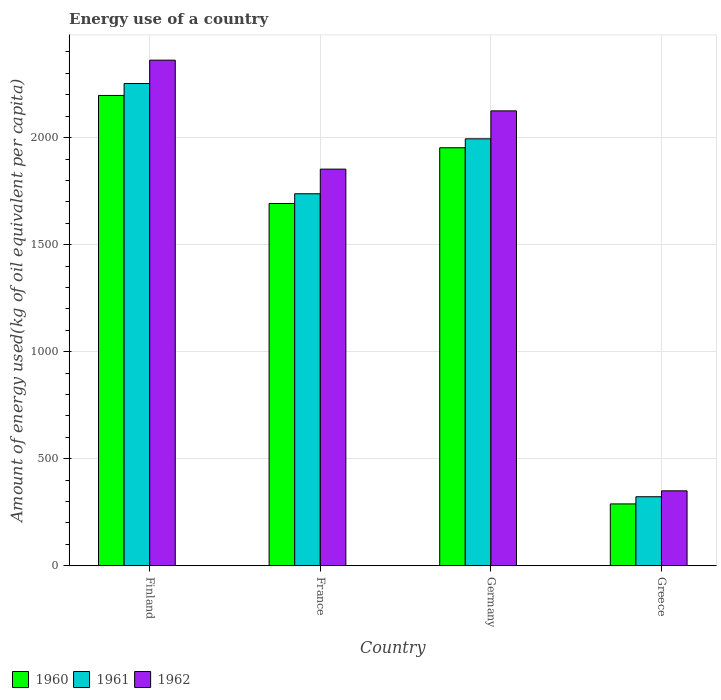How many different coloured bars are there?
Your answer should be compact. 3. Are the number of bars per tick equal to the number of legend labels?
Provide a short and direct response. Yes. Are the number of bars on each tick of the X-axis equal?
Make the answer very short. Yes. What is the label of the 2nd group of bars from the left?
Offer a very short reply. France. What is the amount of energy used in in 1962 in Germany?
Give a very brief answer. 2124.85. Across all countries, what is the maximum amount of energy used in in 1961?
Make the answer very short. 2252.78. Across all countries, what is the minimum amount of energy used in in 1961?
Provide a short and direct response. 322.49. In which country was the amount of energy used in in 1962 maximum?
Provide a succinct answer. Finland. What is the total amount of energy used in in 1961 in the graph?
Keep it short and to the point. 6307.28. What is the difference between the amount of energy used in in 1962 in France and that in Greece?
Make the answer very short. 1502.63. What is the difference between the amount of energy used in in 1961 in Finland and the amount of energy used in in 1960 in Germany?
Provide a short and direct response. 300.19. What is the average amount of energy used in in 1961 per country?
Give a very brief answer. 1576.82. What is the difference between the amount of energy used in of/in 1960 and amount of energy used in of/in 1961 in Germany?
Your response must be concise. -41.74. What is the ratio of the amount of energy used in in 1962 in France to that in Greece?
Your answer should be compact. 5.29. Is the amount of energy used in in 1960 in Germany less than that in Greece?
Your response must be concise. No. Is the difference between the amount of energy used in in 1960 in Finland and France greater than the difference between the amount of energy used in in 1961 in Finland and France?
Your answer should be very brief. No. What is the difference between the highest and the second highest amount of energy used in in 1961?
Your answer should be compact. -256.64. What is the difference between the highest and the lowest amount of energy used in in 1961?
Provide a succinct answer. 1930.29. What does the 3rd bar from the left in Germany represents?
Keep it short and to the point. 1962. What does the 1st bar from the right in Greece represents?
Offer a terse response. 1962. Is it the case that in every country, the sum of the amount of energy used in in 1961 and amount of energy used in in 1962 is greater than the amount of energy used in in 1960?
Offer a very short reply. Yes. Are all the bars in the graph horizontal?
Your response must be concise. No. What is the difference between two consecutive major ticks on the Y-axis?
Your answer should be compact. 500. Are the values on the major ticks of Y-axis written in scientific E-notation?
Ensure brevity in your answer.  No. Where does the legend appear in the graph?
Ensure brevity in your answer.  Bottom left. What is the title of the graph?
Provide a succinct answer. Energy use of a country. What is the label or title of the Y-axis?
Make the answer very short. Amount of energy used(kg of oil equivalent per capita). What is the Amount of energy used(kg of oil equivalent per capita) in 1960 in Finland?
Make the answer very short. 2196.95. What is the Amount of energy used(kg of oil equivalent per capita) in 1961 in Finland?
Make the answer very short. 2252.78. What is the Amount of energy used(kg of oil equivalent per capita) of 1962 in Finland?
Ensure brevity in your answer.  2361.74. What is the Amount of energy used(kg of oil equivalent per capita) in 1960 in France?
Give a very brief answer. 1692.26. What is the Amount of energy used(kg of oil equivalent per capita) in 1961 in France?
Provide a succinct answer. 1737.69. What is the Amount of energy used(kg of oil equivalent per capita) of 1962 in France?
Make the answer very short. 1852.74. What is the Amount of energy used(kg of oil equivalent per capita) of 1960 in Germany?
Provide a succinct answer. 1952.59. What is the Amount of energy used(kg of oil equivalent per capita) of 1961 in Germany?
Offer a terse response. 1994.32. What is the Amount of energy used(kg of oil equivalent per capita) of 1962 in Germany?
Offer a terse response. 2124.85. What is the Amount of energy used(kg of oil equivalent per capita) in 1960 in Greece?
Provide a succinct answer. 289.06. What is the Amount of energy used(kg of oil equivalent per capita) in 1961 in Greece?
Keep it short and to the point. 322.49. What is the Amount of energy used(kg of oil equivalent per capita) in 1962 in Greece?
Offer a very short reply. 350.1. Across all countries, what is the maximum Amount of energy used(kg of oil equivalent per capita) of 1960?
Offer a terse response. 2196.95. Across all countries, what is the maximum Amount of energy used(kg of oil equivalent per capita) of 1961?
Provide a short and direct response. 2252.78. Across all countries, what is the maximum Amount of energy used(kg of oil equivalent per capita) in 1962?
Your answer should be compact. 2361.74. Across all countries, what is the minimum Amount of energy used(kg of oil equivalent per capita) in 1960?
Offer a terse response. 289.06. Across all countries, what is the minimum Amount of energy used(kg of oil equivalent per capita) in 1961?
Keep it short and to the point. 322.49. Across all countries, what is the minimum Amount of energy used(kg of oil equivalent per capita) in 1962?
Provide a succinct answer. 350.1. What is the total Amount of energy used(kg of oil equivalent per capita) in 1960 in the graph?
Your answer should be very brief. 6130.86. What is the total Amount of energy used(kg of oil equivalent per capita) of 1961 in the graph?
Give a very brief answer. 6307.28. What is the total Amount of energy used(kg of oil equivalent per capita) in 1962 in the graph?
Give a very brief answer. 6689.43. What is the difference between the Amount of energy used(kg of oil equivalent per capita) in 1960 in Finland and that in France?
Provide a short and direct response. 504.69. What is the difference between the Amount of energy used(kg of oil equivalent per capita) of 1961 in Finland and that in France?
Offer a very short reply. 515.09. What is the difference between the Amount of energy used(kg of oil equivalent per capita) in 1962 in Finland and that in France?
Give a very brief answer. 509.01. What is the difference between the Amount of energy used(kg of oil equivalent per capita) in 1960 in Finland and that in Germany?
Give a very brief answer. 244.36. What is the difference between the Amount of energy used(kg of oil equivalent per capita) in 1961 in Finland and that in Germany?
Provide a succinct answer. 258.45. What is the difference between the Amount of energy used(kg of oil equivalent per capita) of 1962 in Finland and that in Germany?
Give a very brief answer. 236.9. What is the difference between the Amount of energy used(kg of oil equivalent per capita) in 1960 in Finland and that in Greece?
Provide a succinct answer. 1907.9. What is the difference between the Amount of energy used(kg of oil equivalent per capita) in 1961 in Finland and that in Greece?
Your response must be concise. 1930.29. What is the difference between the Amount of energy used(kg of oil equivalent per capita) in 1962 in Finland and that in Greece?
Offer a terse response. 2011.64. What is the difference between the Amount of energy used(kg of oil equivalent per capita) of 1960 in France and that in Germany?
Make the answer very short. -260.33. What is the difference between the Amount of energy used(kg of oil equivalent per capita) in 1961 in France and that in Germany?
Offer a terse response. -256.64. What is the difference between the Amount of energy used(kg of oil equivalent per capita) in 1962 in France and that in Germany?
Your response must be concise. -272.11. What is the difference between the Amount of energy used(kg of oil equivalent per capita) of 1960 in France and that in Greece?
Make the answer very short. 1403.2. What is the difference between the Amount of energy used(kg of oil equivalent per capita) of 1961 in France and that in Greece?
Make the answer very short. 1415.2. What is the difference between the Amount of energy used(kg of oil equivalent per capita) in 1962 in France and that in Greece?
Your response must be concise. 1502.63. What is the difference between the Amount of energy used(kg of oil equivalent per capita) in 1960 in Germany and that in Greece?
Keep it short and to the point. 1663.53. What is the difference between the Amount of energy used(kg of oil equivalent per capita) of 1961 in Germany and that in Greece?
Provide a short and direct response. 1671.83. What is the difference between the Amount of energy used(kg of oil equivalent per capita) of 1962 in Germany and that in Greece?
Make the answer very short. 1774.75. What is the difference between the Amount of energy used(kg of oil equivalent per capita) of 1960 in Finland and the Amount of energy used(kg of oil equivalent per capita) of 1961 in France?
Offer a very short reply. 459.26. What is the difference between the Amount of energy used(kg of oil equivalent per capita) in 1960 in Finland and the Amount of energy used(kg of oil equivalent per capita) in 1962 in France?
Offer a very short reply. 344.22. What is the difference between the Amount of energy used(kg of oil equivalent per capita) in 1961 in Finland and the Amount of energy used(kg of oil equivalent per capita) in 1962 in France?
Offer a terse response. 400.04. What is the difference between the Amount of energy used(kg of oil equivalent per capita) of 1960 in Finland and the Amount of energy used(kg of oil equivalent per capita) of 1961 in Germany?
Your answer should be compact. 202.63. What is the difference between the Amount of energy used(kg of oil equivalent per capita) in 1960 in Finland and the Amount of energy used(kg of oil equivalent per capita) in 1962 in Germany?
Your answer should be compact. 72.1. What is the difference between the Amount of energy used(kg of oil equivalent per capita) in 1961 in Finland and the Amount of energy used(kg of oil equivalent per capita) in 1962 in Germany?
Offer a terse response. 127.93. What is the difference between the Amount of energy used(kg of oil equivalent per capita) in 1960 in Finland and the Amount of energy used(kg of oil equivalent per capita) in 1961 in Greece?
Give a very brief answer. 1874.46. What is the difference between the Amount of energy used(kg of oil equivalent per capita) of 1960 in Finland and the Amount of energy used(kg of oil equivalent per capita) of 1962 in Greece?
Offer a terse response. 1846.85. What is the difference between the Amount of energy used(kg of oil equivalent per capita) in 1961 in Finland and the Amount of energy used(kg of oil equivalent per capita) in 1962 in Greece?
Your answer should be compact. 1902.68. What is the difference between the Amount of energy used(kg of oil equivalent per capita) in 1960 in France and the Amount of energy used(kg of oil equivalent per capita) in 1961 in Germany?
Your answer should be very brief. -302.06. What is the difference between the Amount of energy used(kg of oil equivalent per capita) of 1960 in France and the Amount of energy used(kg of oil equivalent per capita) of 1962 in Germany?
Ensure brevity in your answer.  -432.59. What is the difference between the Amount of energy used(kg of oil equivalent per capita) in 1961 in France and the Amount of energy used(kg of oil equivalent per capita) in 1962 in Germany?
Your answer should be very brief. -387.16. What is the difference between the Amount of energy used(kg of oil equivalent per capita) of 1960 in France and the Amount of energy used(kg of oil equivalent per capita) of 1961 in Greece?
Keep it short and to the point. 1369.77. What is the difference between the Amount of energy used(kg of oil equivalent per capita) of 1960 in France and the Amount of energy used(kg of oil equivalent per capita) of 1962 in Greece?
Make the answer very short. 1342.16. What is the difference between the Amount of energy used(kg of oil equivalent per capita) in 1961 in France and the Amount of energy used(kg of oil equivalent per capita) in 1962 in Greece?
Ensure brevity in your answer.  1387.59. What is the difference between the Amount of energy used(kg of oil equivalent per capita) in 1960 in Germany and the Amount of energy used(kg of oil equivalent per capita) in 1961 in Greece?
Offer a very short reply. 1630.1. What is the difference between the Amount of energy used(kg of oil equivalent per capita) of 1960 in Germany and the Amount of energy used(kg of oil equivalent per capita) of 1962 in Greece?
Offer a terse response. 1602.49. What is the difference between the Amount of energy used(kg of oil equivalent per capita) in 1961 in Germany and the Amount of energy used(kg of oil equivalent per capita) in 1962 in Greece?
Make the answer very short. 1644.22. What is the average Amount of energy used(kg of oil equivalent per capita) in 1960 per country?
Offer a very short reply. 1532.72. What is the average Amount of energy used(kg of oil equivalent per capita) in 1961 per country?
Keep it short and to the point. 1576.82. What is the average Amount of energy used(kg of oil equivalent per capita) in 1962 per country?
Provide a succinct answer. 1672.36. What is the difference between the Amount of energy used(kg of oil equivalent per capita) in 1960 and Amount of energy used(kg of oil equivalent per capita) in 1961 in Finland?
Your response must be concise. -55.83. What is the difference between the Amount of energy used(kg of oil equivalent per capita) of 1960 and Amount of energy used(kg of oil equivalent per capita) of 1962 in Finland?
Offer a very short reply. -164.79. What is the difference between the Amount of energy used(kg of oil equivalent per capita) of 1961 and Amount of energy used(kg of oil equivalent per capita) of 1962 in Finland?
Provide a short and direct response. -108.97. What is the difference between the Amount of energy used(kg of oil equivalent per capita) of 1960 and Amount of energy used(kg of oil equivalent per capita) of 1961 in France?
Your answer should be compact. -45.43. What is the difference between the Amount of energy used(kg of oil equivalent per capita) in 1960 and Amount of energy used(kg of oil equivalent per capita) in 1962 in France?
Offer a terse response. -160.47. What is the difference between the Amount of energy used(kg of oil equivalent per capita) of 1961 and Amount of energy used(kg of oil equivalent per capita) of 1962 in France?
Your answer should be very brief. -115.05. What is the difference between the Amount of energy used(kg of oil equivalent per capita) in 1960 and Amount of energy used(kg of oil equivalent per capita) in 1961 in Germany?
Your answer should be very brief. -41.74. What is the difference between the Amount of energy used(kg of oil equivalent per capita) of 1960 and Amount of energy used(kg of oil equivalent per capita) of 1962 in Germany?
Offer a terse response. -172.26. What is the difference between the Amount of energy used(kg of oil equivalent per capita) in 1961 and Amount of energy used(kg of oil equivalent per capita) in 1962 in Germany?
Your response must be concise. -130.52. What is the difference between the Amount of energy used(kg of oil equivalent per capita) in 1960 and Amount of energy used(kg of oil equivalent per capita) in 1961 in Greece?
Your answer should be compact. -33.43. What is the difference between the Amount of energy used(kg of oil equivalent per capita) of 1960 and Amount of energy used(kg of oil equivalent per capita) of 1962 in Greece?
Give a very brief answer. -61.04. What is the difference between the Amount of energy used(kg of oil equivalent per capita) of 1961 and Amount of energy used(kg of oil equivalent per capita) of 1962 in Greece?
Your answer should be very brief. -27.61. What is the ratio of the Amount of energy used(kg of oil equivalent per capita) in 1960 in Finland to that in France?
Provide a short and direct response. 1.3. What is the ratio of the Amount of energy used(kg of oil equivalent per capita) of 1961 in Finland to that in France?
Your response must be concise. 1.3. What is the ratio of the Amount of energy used(kg of oil equivalent per capita) in 1962 in Finland to that in France?
Ensure brevity in your answer.  1.27. What is the ratio of the Amount of energy used(kg of oil equivalent per capita) of 1960 in Finland to that in Germany?
Your response must be concise. 1.13. What is the ratio of the Amount of energy used(kg of oil equivalent per capita) in 1961 in Finland to that in Germany?
Ensure brevity in your answer.  1.13. What is the ratio of the Amount of energy used(kg of oil equivalent per capita) in 1962 in Finland to that in Germany?
Provide a short and direct response. 1.11. What is the ratio of the Amount of energy used(kg of oil equivalent per capita) in 1960 in Finland to that in Greece?
Offer a terse response. 7.6. What is the ratio of the Amount of energy used(kg of oil equivalent per capita) of 1961 in Finland to that in Greece?
Make the answer very short. 6.99. What is the ratio of the Amount of energy used(kg of oil equivalent per capita) in 1962 in Finland to that in Greece?
Your response must be concise. 6.75. What is the ratio of the Amount of energy used(kg of oil equivalent per capita) of 1960 in France to that in Germany?
Give a very brief answer. 0.87. What is the ratio of the Amount of energy used(kg of oil equivalent per capita) in 1961 in France to that in Germany?
Keep it short and to the point. 0.87. What is the ratio of the Amount of energy used(kg of oil equivalent per capita) of 1962 in France to that in Germany?
Keep it short and to the point. 0.87. What is the ratio of the Amount of energy used(kg of oil equivalent per capita) in 1960 in France to that in Greece?
Offer a terse response. 5.85. What is the ratio of the Amount of energy used(kg of oil equivalent per capita) of 1961 in France to that in Greece?
Ensure brevity in your answer.  5.39. What is the ratio of the Amount of energy used(kg of oil equivalent per capita) in 1962 in France to that in Greece?
Provide a short and direct response. 5.29. What is the ratio of the Amount of energy used(kg of oil equivalent per capita) in 1960 in Germany to that in Greece?
Provide a short and direct response. 6.75. What is the ratio of the Amount of energy used(kg of oil equivalent per capita) of 1961 in Germany to that in Greece?
Ensure brevity in your answer.  6.18. What is the ratio of the Amount of energy used(kg of oil equivalent per capita) in 1962 in Germany to that in Greece?
Offer a terse response. 6.07. What is the difference between the highest and the second highest Amount of energy used(kg of oil equivalent per capita) of 1960?
Offer a terse response. 244.36. What is the difference between the highest and the second highest Amount of energy used(kg of oil equivalent per capita) in 1961?
Offer a terse response. 258.45. What is the difference between the highest and the second highest Amount of energy used(kg of oil equivalent per capita) in 1962?
Provide a succinct answer. 236.9. What is the difference between the highest and the lowest Amount of energy used(kg of oil equivalent per capita) of 1960?
Provide a succinct answer. 1907.9. What is the difference between the highest and the lowest Amount of energy used(kg of oil equivalent per capita) of 1961?
Offer a very short reply. 1930.29. What is the difference between the highest and the lowest Amount of energy used(kg of oil equivalent per capita) of 1962?
Give a very brief answer. 2011.64. 